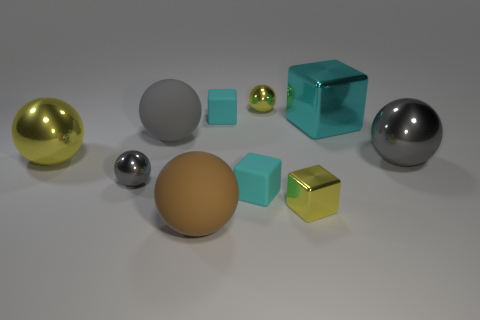Subtract all cyan blocks. How many were subtracted if there are1cyan blocks left? 2 Subtract all matte balls. How many balls are left? 4 Subtract 1 balls. How many balls are left? 5 Subtract all yellow blocks. How many blocks are left? 3 Add 1 small cyan matte things. How many small cyan matte things are left? 3 Add 4 big gray balls. How many big gray balls exist? 6 Subtract 1 cyan cubes. How many objects are left? 9 Subtract all spheres. How many objects are left? 4 Subtract all blue balls. Subtract all red blocks. How many balls are left? 6 Subtract all cyan spheres. How many yellow blocks are left? 1 